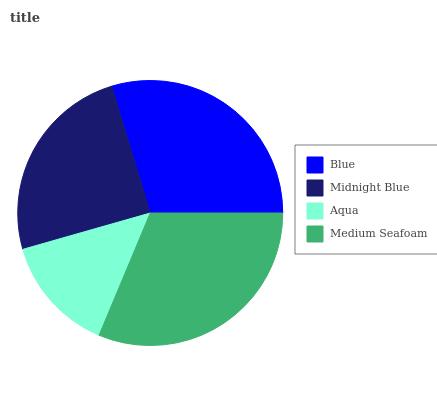Is Aqua the minimum?
Answer yes or no. Yes. Is Medium Seafoam the maximum?
Answer yes or no. Yes. Is Midnight Blue the minimum?
Answer yes or no. No. Is Midnight Blue the maximum?
Answer yes or no. No. Is Blue greater than Midnight Blue?
Answer yes or no. Yes. Is Midnight Blue less than Blue?
Answer yes or no. Yes. Is Midnight Blue greater than Blue?
Answer yes or no. No. Is Blue less than Midnight Blue?
Answer yes or no. No. Is Blue the high median?
Answer yes or no. Yes. Is Midnight Blue the low median?
Answer yes or no. Yes. Is Midnight Blue the high median?
Answer yes or no. No. Is Medium Seafoam the low median?
Answer yes or no. No. 